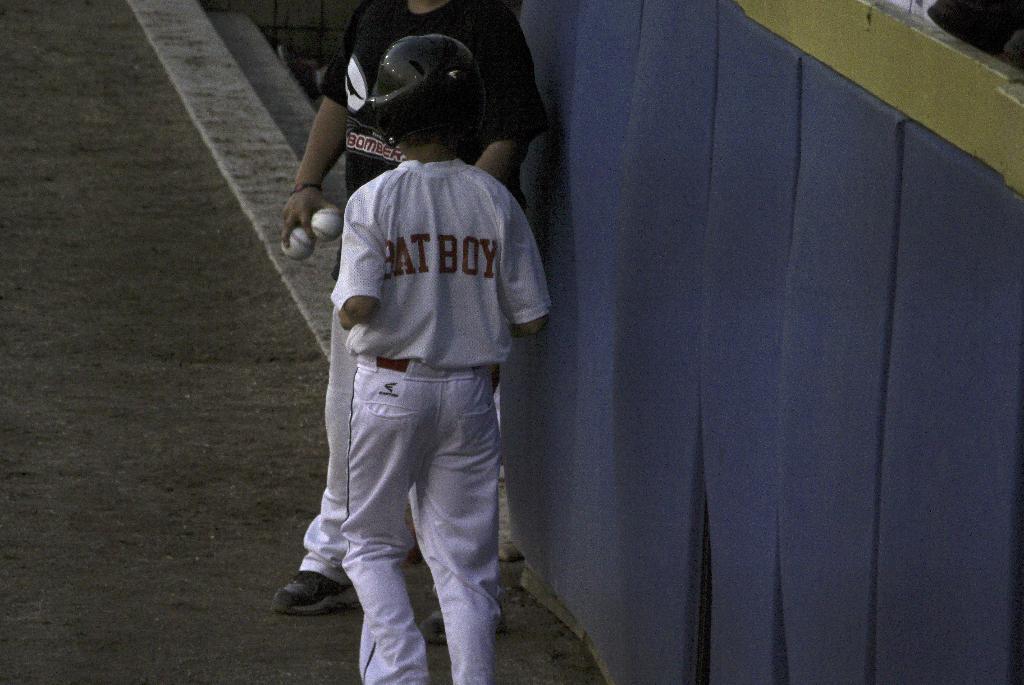What is the name on the back of the baseball shirt?
Give a very brief answer. Bat boy. 